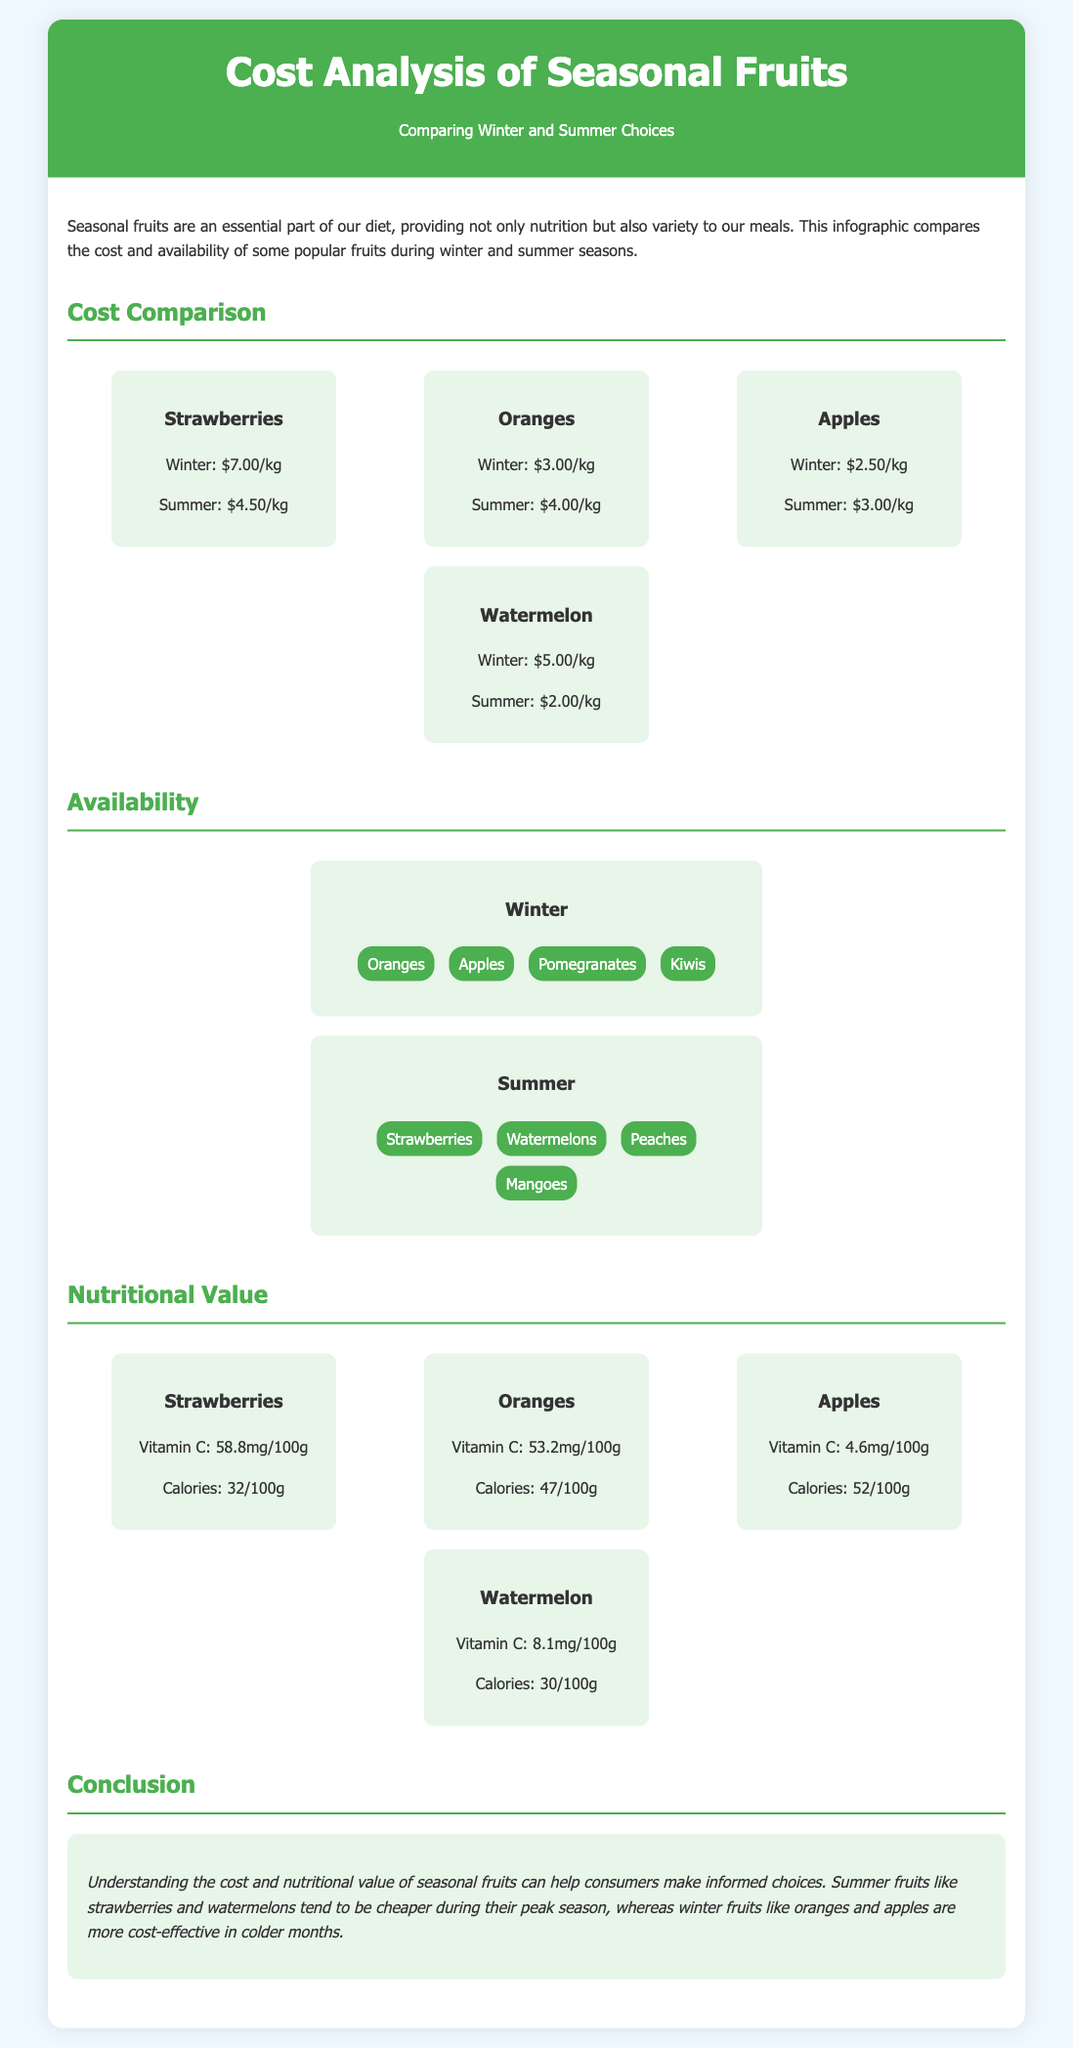What is the cost of strawberries in winter? The cost of strawberries in winter is stated in the document as $7.00/kg.
Answer: $7.00/kg Which fruit is the cheapest in summer? The document shows that watermelon costs $2.00/kg in summer, making it the cheapest.
Answer: Watermelon How many fruits are listed for winter availability? There are four fruits mentioned for winter availability in the document: oranges, apples, pomegranates, and kiwis.
Answer: 4 What is the vitamin C content of apples? The document states that apples contain 4.6mg of Vitamin C per 100g.
Answer: 4.6mg Which season is associated with the highest cost for oranges? The document indicates that oranges are more expensive in summer at $4.00/kg compared to winter.
Answer: Summer What common nutritional measurement is provided for all fruits? The document lists both Vitamin C content and Calories per 100g for each fruit, indicating a common measurement.
Answer: Vitamin C and Calories What is the price difference for watermelon between winter and summer? The document shows that watermelon costs $5.00/kg in winter and $2.00/kg in summer, making the difference $3.00/kg.
Answer: $3.00/kg Which fruits are available in summer? The document enumerates strawberries, watermelons, peaches, and mangoes as available in summer.
Answer: Strawberries, Watermelons, Peaches, Mangoes What conclusion is drawn about the cost of summer fruits? The document concludes that summer fruits like strawberries and watermelons tend to be cheaper during their peak season.
Answer: Cheaper in summer 